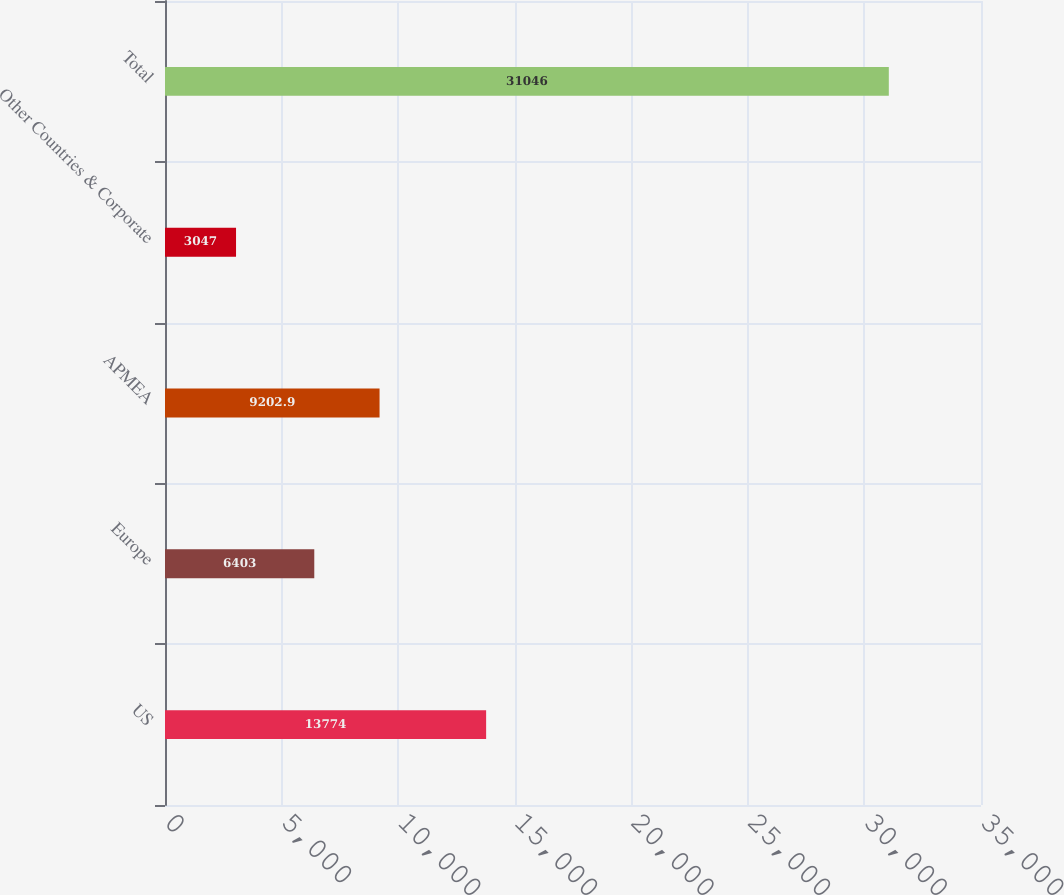Convert chart. <chart><loc_0><loc_0><loc_500><loc_500><bar_chart><fcel>US<fcel>Europe<fcel>APMEA<fcel>Other Countries & Corporate<fcel>Total<nl><fcel>13774<fcel>6403<fcel>9202.9<fcel>3047<fcel>31046<nl></chart> 